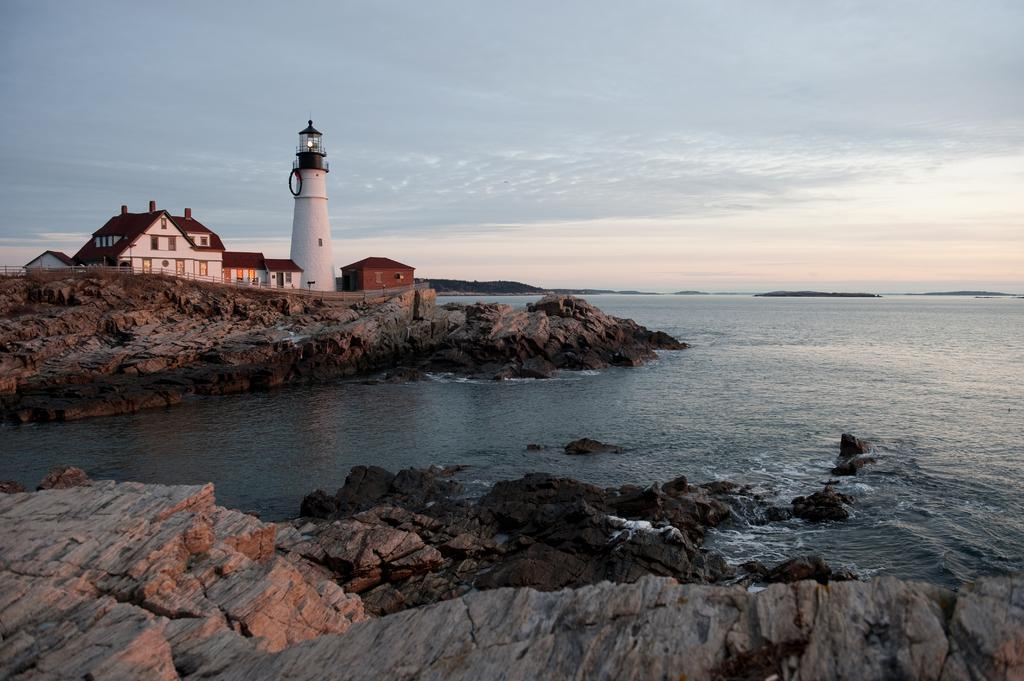What is the primary element visible in the image? There is water in the image. What other objects can be seen in the water? There are rocks in the image. What can be seen in the background of the image? There are buildings and a lighthouse in the background of the image. What is visible above the buildings and lighthouse? The sky is visible in the background of the image. How many needles are floating in the water in the image? There are no needles visible in the image; it features water, rocks, buildings, a lighthouse, and the sky. What type of boats can be seen in the image? There are no boats present in the image. 